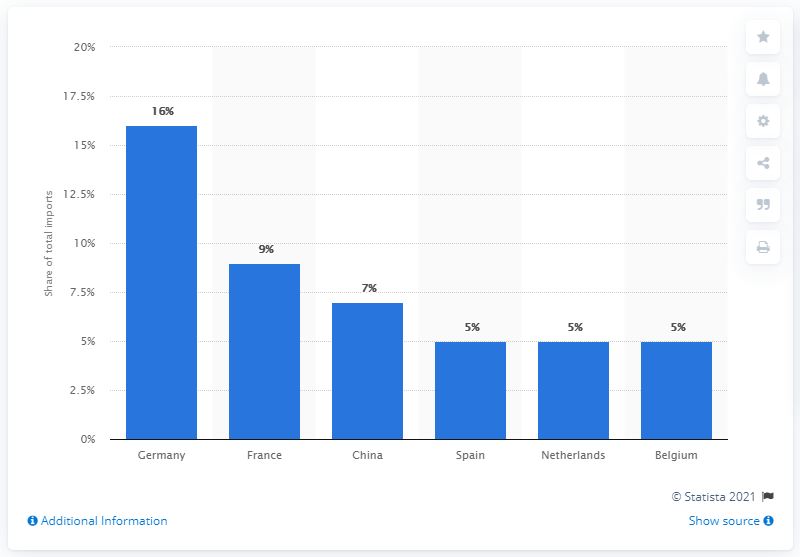Indicate a few pertinent items in this graphic. In 2019, Italy's most significant import partner was Germany. 